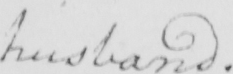Please provide the text content of this handwritten line. husband . 